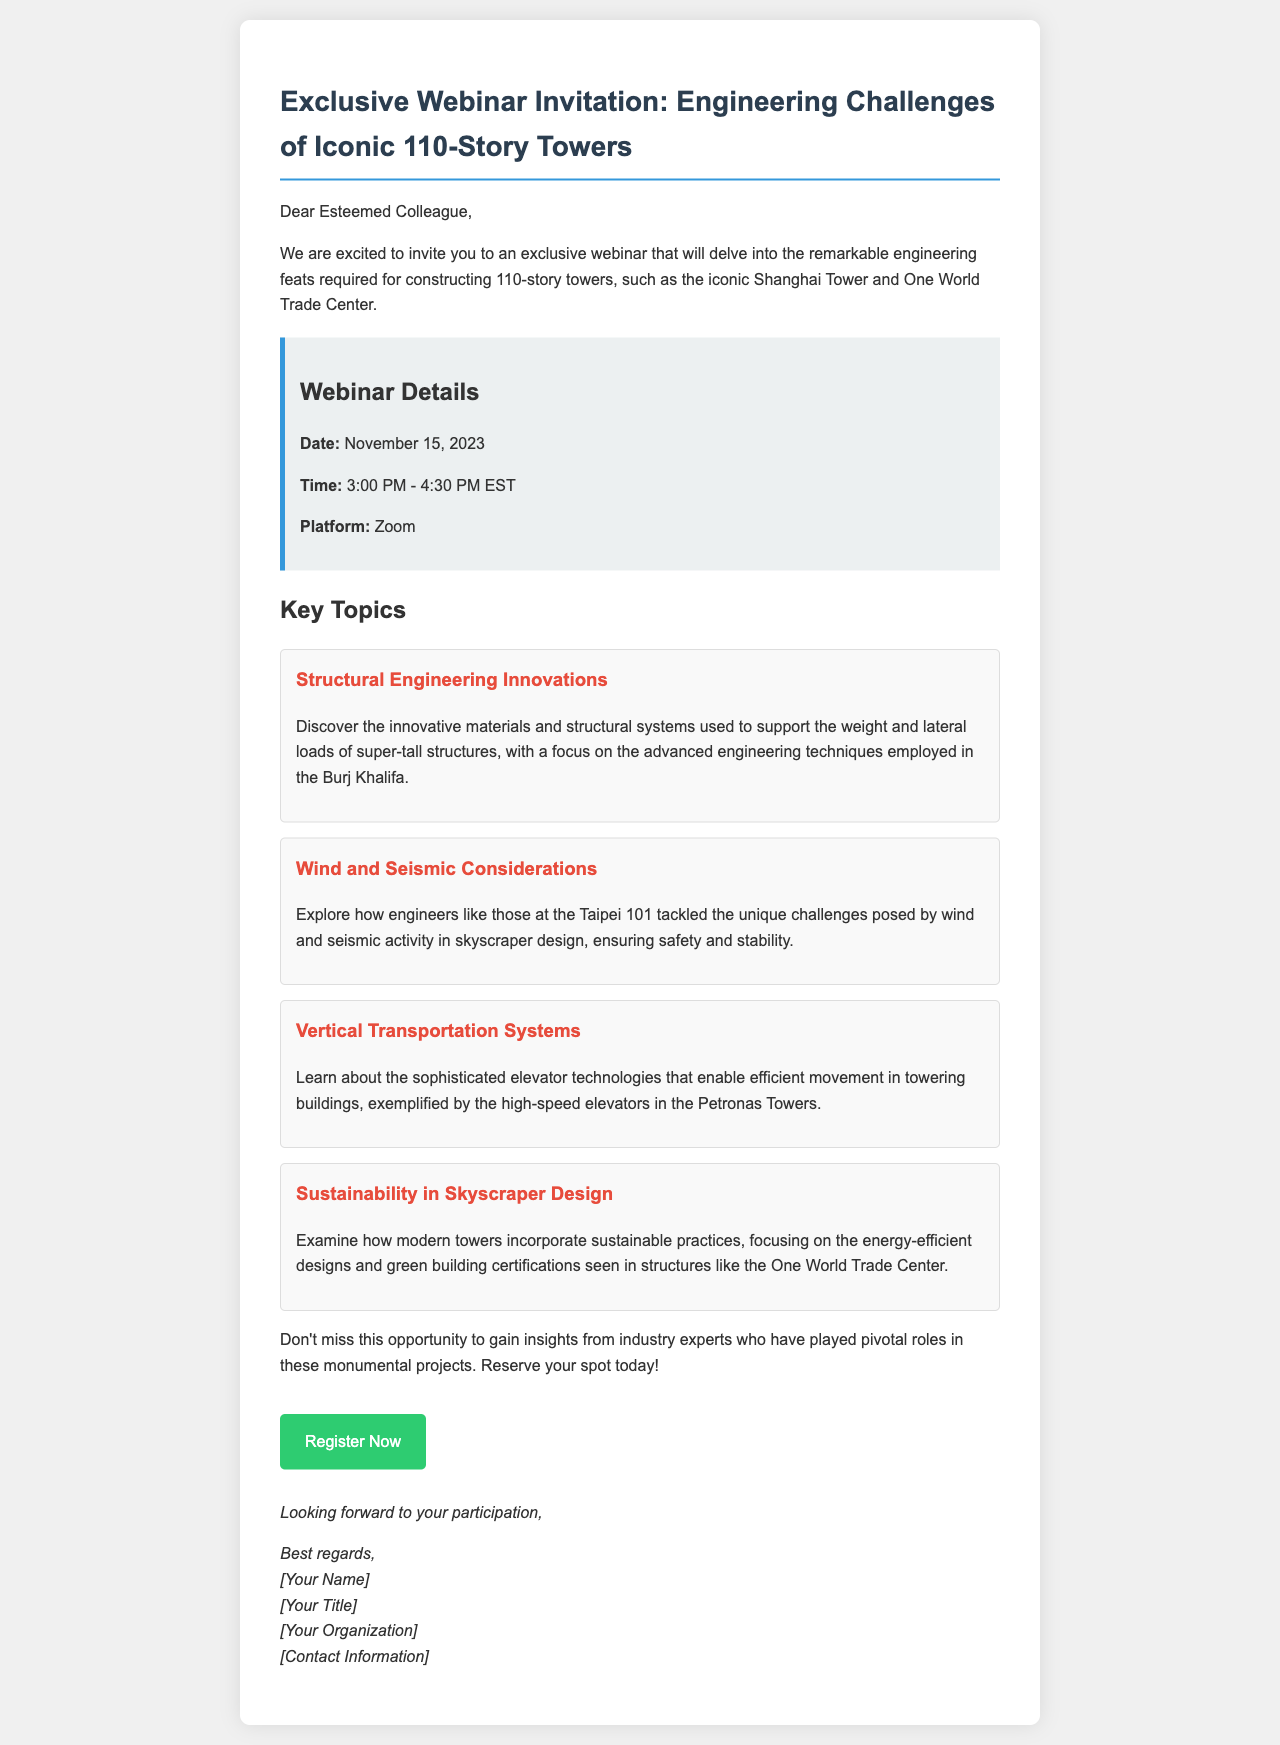What is the date of the webinar? The date of the webinar is mentioned in the document.
Answer: November 15, 2023 What is the duration of the webinar? The document states the time for the webinar and implies the duration.
Answer: 1.5 hours Which platform will the webinar be held on? The platform for the webinar is specified in the document as the medium for the event.
Answer: Zoom What is one of the key topics discussed? The document lists several topics that will be covered in the webinar.
Answer: Structural Engineering Innovations Which iconic tower is highlighted in the context of advanced engineering techniques? The document notes specific towers related to the topics being discussed.
Answer: Burj Khalifa What time does the webinar start? The starting time of the webinar is explicitly provided in the document.
Answer: 3:00 PM What color is the background of the webinar details section? The document contains a description of the colors used in the layout.
Answer: Light gray Who is the intended audience for the email? The salutation indicates the target recipients of the email invitation.
Answer: Esteemed Colleague 